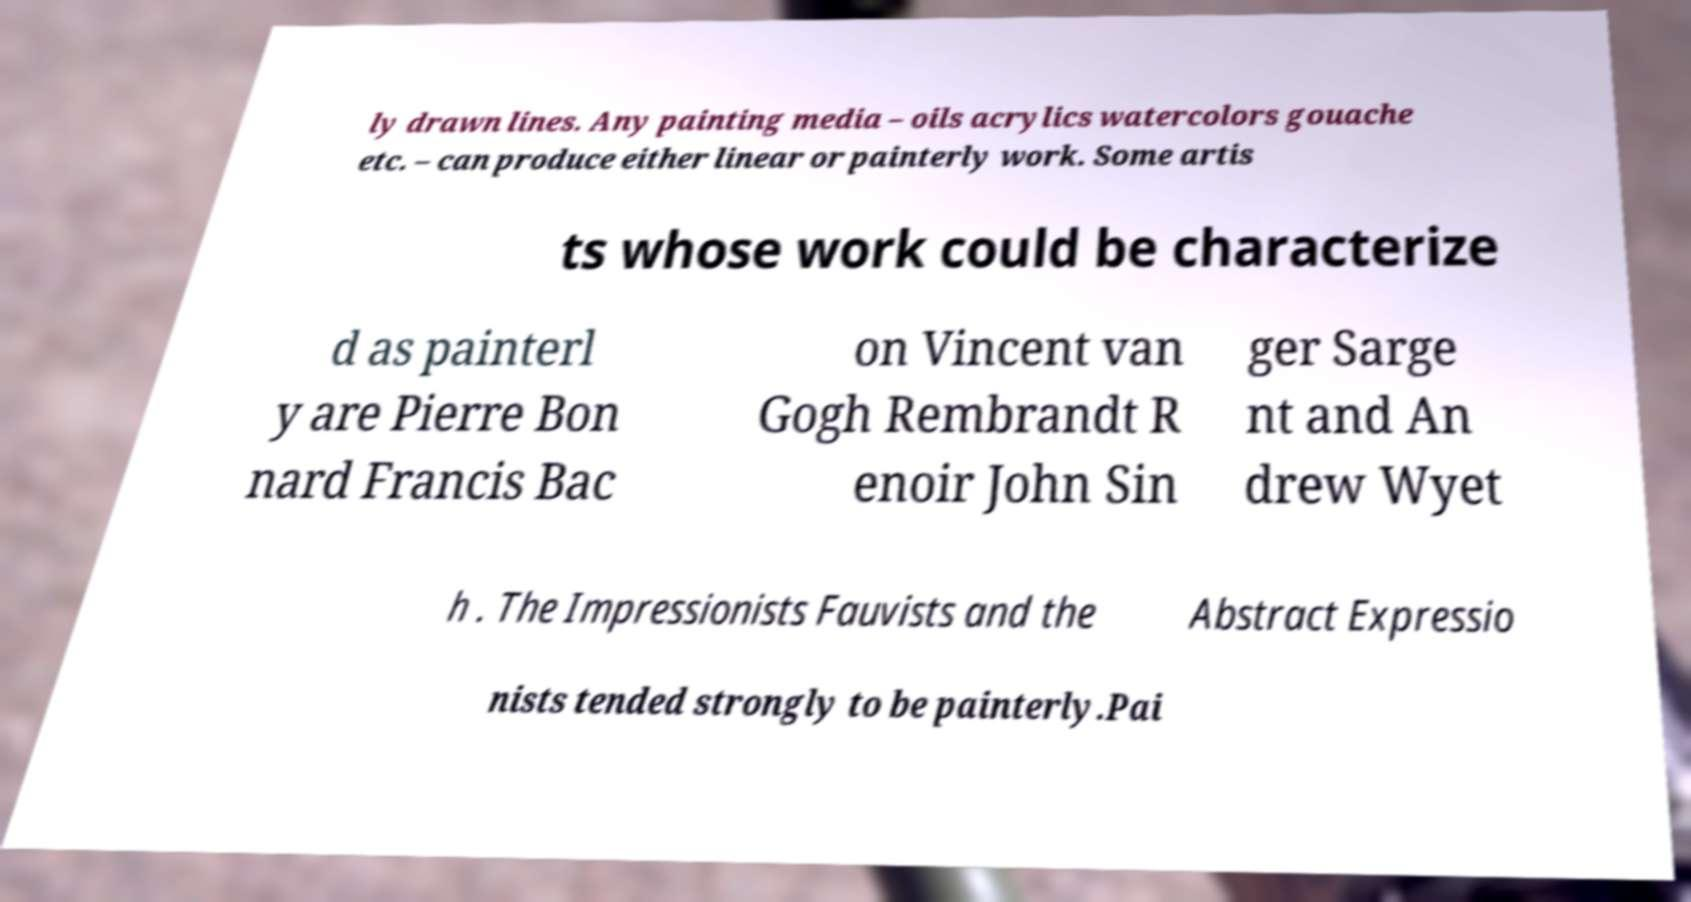There's text embedded in this image that I need extracted. Can you transcribe it verbatim? ly drawn lines. Any painting media – oils acrylics watercolors gouache etc. – can produce either linear or painterly work. Some artis ts whose work could be characterize d as painterl y are Pierre Bon nard Francis Bac on Vincent van Gogh Rembrandt R enoir John Sin ger Sarge nt and An drew Wyet h . The Impressionists Fauvists and the Abstract Expressio nists tended strongly to be painterly.Pai 